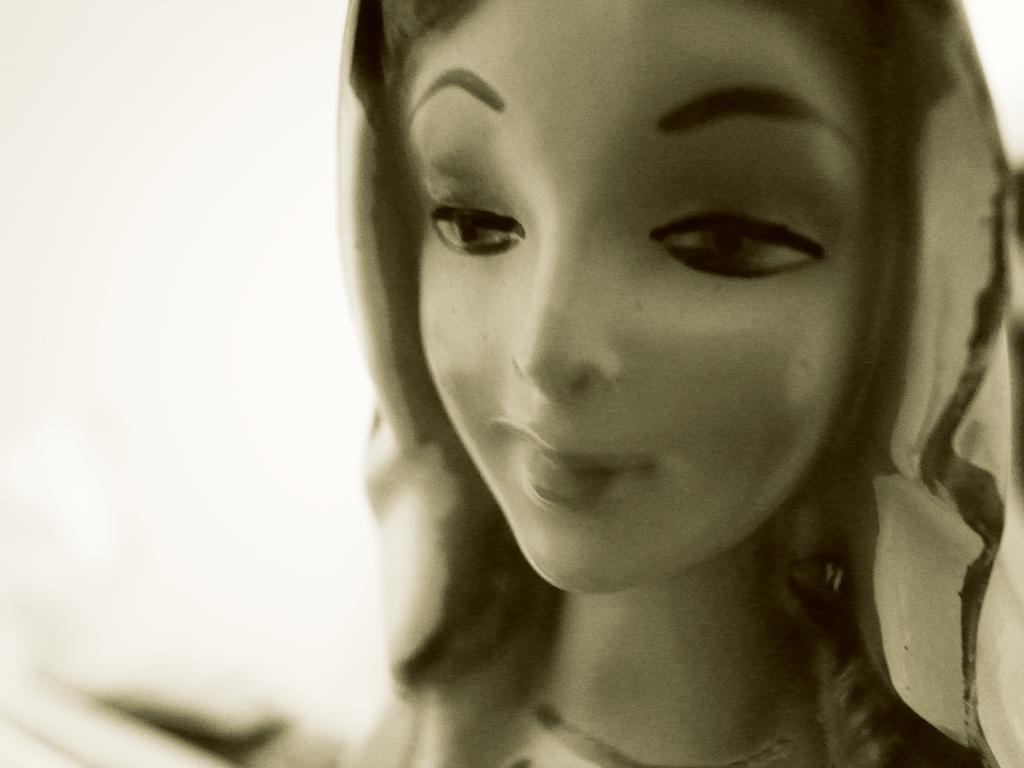Please provide a concise description of this image. In this image we can see a statue of a lady. 